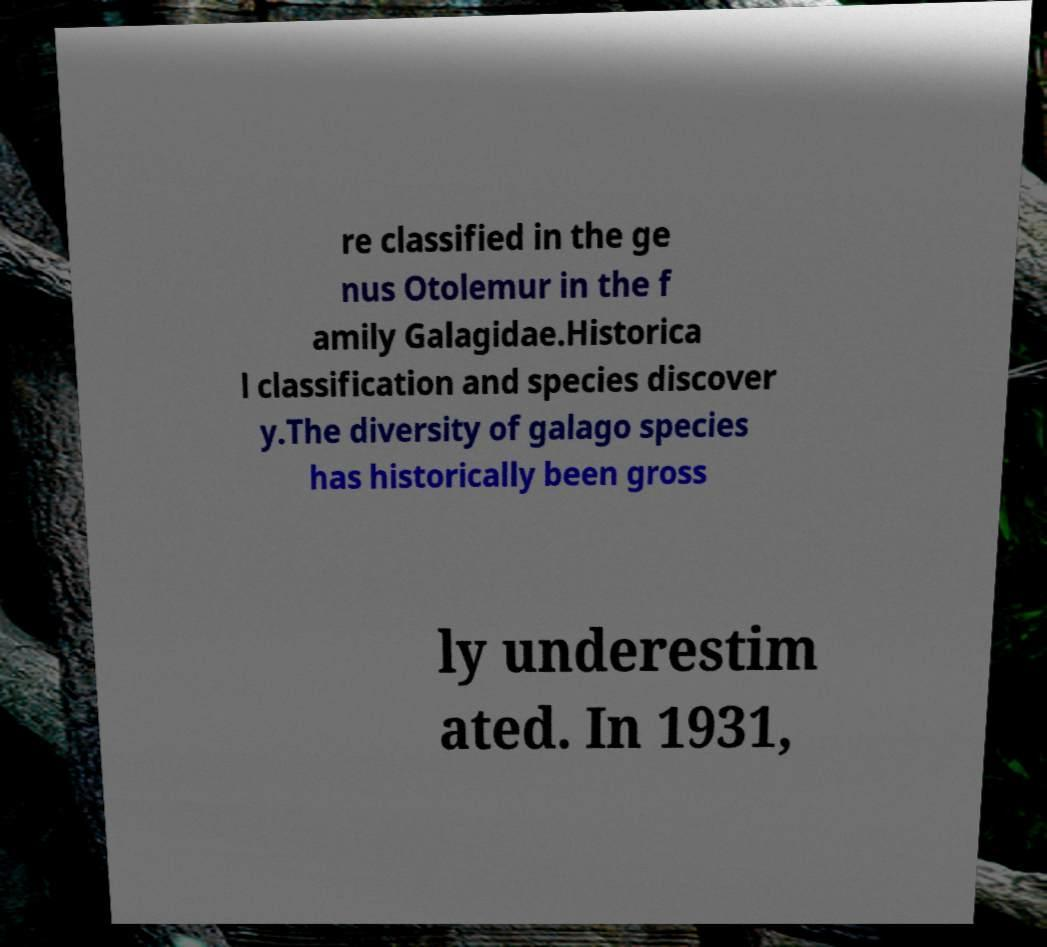There's text embedded in this image that I need extracted. Can you transcribe it verbatim? re classified in the ge nus Otolemur in the f amily Galagidae.Historica l classification and species discover y.The diversity of galago species has historically been gross ly underestim ated. In 1931, 